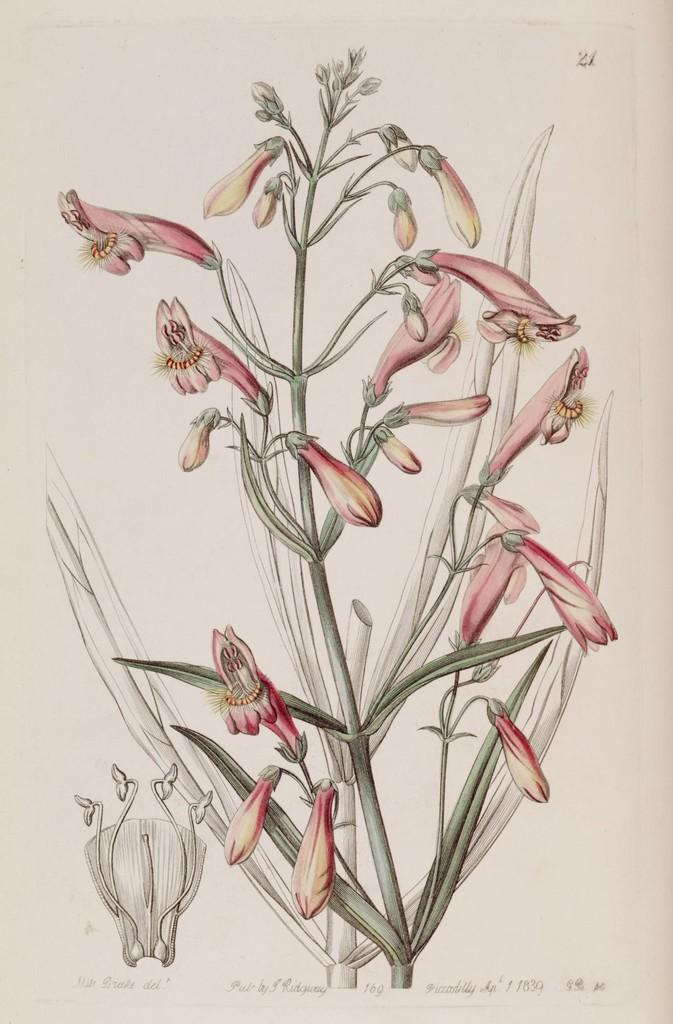What type of artwork is depicted in the image? The image is a painting. What is the main subject of the painting? There is a picture of a plant in the middle of the image. Is there any text present in the painting? Yes, there is text written at the bottom of the image. What type of linen is used to create the painting? The painting is not made of linen; it is a two-dimensional representation of a plant on a surface. What surprise can be found hidden within the painting? There is no mention of a hidden surprise within the painting; it simply depicts a plant with text at the bottom. 